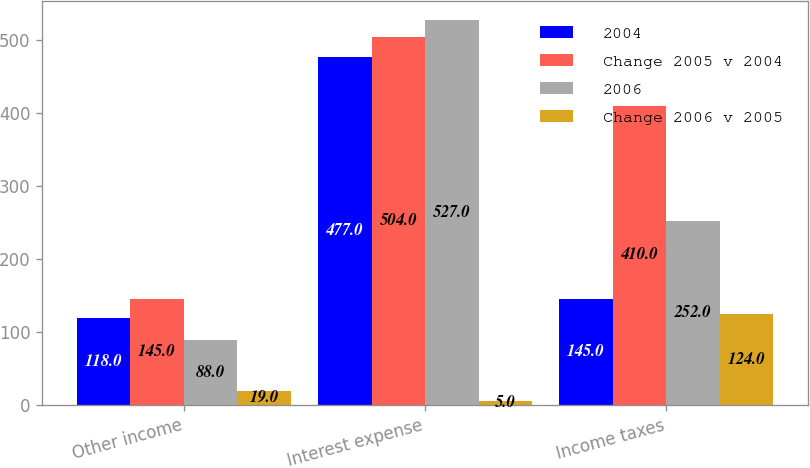<chart> <loc_0><loc_0><loc_500><loc_500><stacked_bar_chart><ecel><fcel>Other income<fcel>Interest expense<fcel>Income taxes<nl><fcel>2004<fcel>118<fcel>477<fcel>145<nl><fcel>Change 2005 v 2004<fcel>145<fcel>504<fcel>410<nl><fcel>2006<fcel>88<fcel>527<fcel>252<nl><fcel>Change 2006 v 2005<fcel>19<fcel>5<fcel>124<nl></chart> 